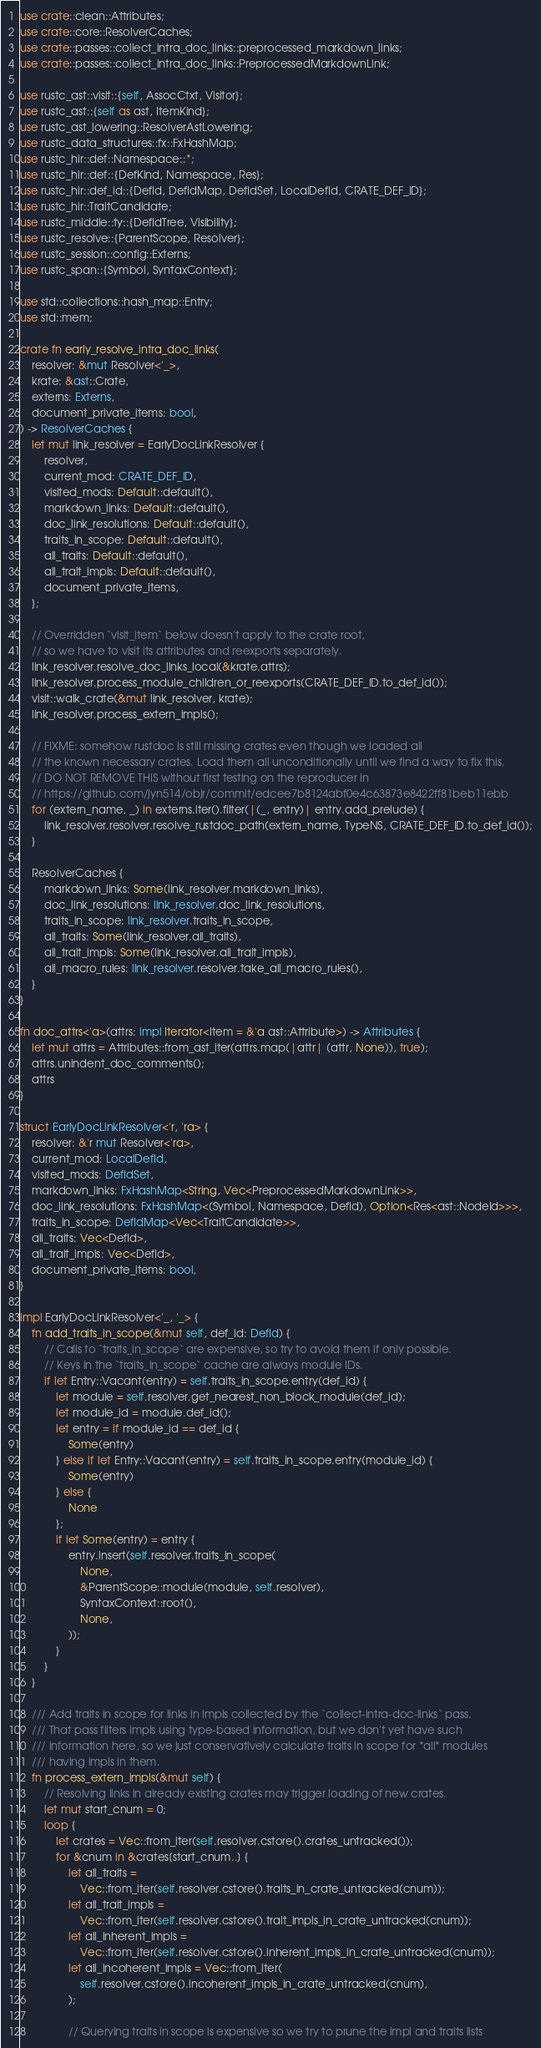<code> <loc_0><loc_0><loc_500><loc_500><_Rust_>use crate::clean::Attributes;
use crate::core::ResolverCaches;
use crate::passes::collect_intra_doc_links::preprocessed_markdown_links;
use crate::passes::collect_intra_doc_links::PreprocessedMarkdownLink;

use rustc_ast::visit::{self, AssocCtxt, Visitor};
use rustc_ast::{self as ast, ItemKind};
use rustc_ast_lowering::ResolverAstLowering;
use rustc_data_structures::fx::FxHashMap;
use rustc_hir::def::Namespace::*;
use rustc_hir::def::{DefKind, Namespace, Res};
use rustc_hir::def_id::{DefId, DefIdMap, DefIdSet, LocalDefId, CRATE_DEF_ID};
use rustc_hir::TraitCandidate;
use rustc_middle::ty::{DefIdTree, Visibility};
use rustc_resolve::{ParentScope, Resolver};
use rustc_session::config::Externs;
use rustc_span::{Symbol, SyntaxContext};

use std::collections::hash_map::Entry;
use std::mem;

crate fn early_resolve_intra_doc_links(
    resolver: &mut Resolver<'_>,
    krate: &ast::Crate,
    externs: Externs,
    document_private_items: bool,
) -> ResolverCaches {
    let mut link_resolver = EarlyDocLinkResolver {
        resolver,
        current_mod: CRATE_DEF_ID,
        visited_mods: Default::default(),
        markdown_links: Default::default(),
        doc_link_resolutions: Default::default(),
        traits_in_scope: Default::default(),
        all_traits: Default::default(),
        all_trait_impls: Default::default(),
        document_private_items,
    };

    // Overridden `visit_item` below doesn't apply to the crate root,
    // so we have to visit its attributes and reexports separately.
    link_resolver.resolve_doc_links_local(&krate.attrs);
    link_resolver.process_module_children_or_reexports(CRATE_DEF_ID.to_def_id());
    visit::walk_crate(&mut link_resolver, krate);
    link_resolver.process_extern_impls();

    // FIXME: somehow rustdoc is still missing crates even though we loaded all
    // the known necessary crates. Load them all unconditionally until we find a way to fix this.
    // DO NOT REMOVE THIS without first testing on the reproducer in
    // https://github.com/jyn514/objr/commit/edcee7b8124abf0e4c63873e8422ff81beb11ebb
    for (extern_name, _) in externs.iter().filter(|(_, entry)| entry.add_prelude) {
        link_resolver.resolver.resolve_rustdoc_path(extern_name, TypeNS, CRATE_DEF_ID.to_def_id());
    }

    ResolverCaches {
        markdown_links: Some(link_resolver.markdown_links),
        doc_link_resolutions: link_resolver.doc_link_resolutions,
        traits_in_scope: link_resolver.traits_in_scope,
        all_traits: Some(link_resolver.all_traits),
        all_trait_impls: Some(link_resolver.all_trait_impls),
        all_macro_rules: link_resolver.resolver.take_all_macro_rules(),
    }
}

fn doc_attrs<'a>(attrs: impl Iterator<Item = &'a ast::Attribute>) -> Attributes {
    let mut attrs = Attributes::from_ast_iter(attrs.map(|attr| (attr, None)), true);
    attrs.unindent_doc_comments();
    attrs
}

struct EarlyDocLinkResolver<'r, 'ra> {
    resolver: &'r mut Resolver<'ra>,
    current_mod: LocalDefId,
    visited_mods: DefIdSet,
    markdown_links: FxHashMap<String, Vec<PreprocessedMarkdownLink>>,
    doc_link_resolutions: FxHashMap<(Symbol, Namespace, DefId), Option<Res<ast::NodeId>>>,
    traits_in_scope: DefIdMap<Vec<TraitCandidate>>,
    all_traits: Vec<DefId>,
    all_trait_impls: Vec<DefId>,
    document_private_items: bool,
}

impl EarlyDocLinkResolver<'_, '_> {
    fn add_traits_in_scope(&mut self, def_id: DefId) {
        // Calls to `traits_in_scope` are expensive, so try to avoid them if only possible.
        // Keys in the `traits_in_scope` cache are always module IDs.
        if let Entry::Vacant(entry) = self.traits_in_scope.entry(def_id) {
            let module = self.resolver.get_nearest_non_block_module(def_id);
            let module_id = module.def_id();
            let entry = if module_id == def_id {
                Some(entry)
            } else if let Entry::Vacant(entry) = self.traits_in_scope.entry(module_id) {
                Some(entry)
            } else {
                None
            };
            if let Some(entry) = entry {
                entry.insert(self.resolver.traits_in_scope(
                    None,
                    &ParentScope::module(module, self.resolver),
                    SyntaxContext::root(),
                    None,
                ));
            }
        }
    }

    /// Add traits in scope for links in impls collected by the `collect-intra-doc-links` pass.
    /// That pass filters impls using type-based information, but we don't yet have such
    /// information here, so we just conservatively calculate traits in scope for *all* modules
    /// having impls in them.
    fn process_extern_impls(&mut self) {
        // Resolving links in already existing crates may trigger loading of new crates.
        let mut start_cnum = 0;
        loop {
            let crates = Vec::from_iter(self.resolver.cstore().crates_untracked());
            for &cnum in &crates[start_cnum..] {
                let all_traits =
                    Vec::from_iter(self.resolver.cstore().traits_in_crate_untracked(cnum));
                let all_trait_impls =
                    Vec::from_iter(self.resolver.cstore().trait_impls_in_crate_untracked(cnum));
                let all_inherent_impls =
                    Vec::from_iter(self.resolver.cstore().inherent_impls_in_crate_untracked(cnum));
                let all_incoherent_impls = Vec::from_iter(
                    self.resolver.cstore().incoherent_impls_in_crate_untracked(cnum),
                );

                // Querying traits in scope is expensive so we try to prune the impl and traits lists</code> 